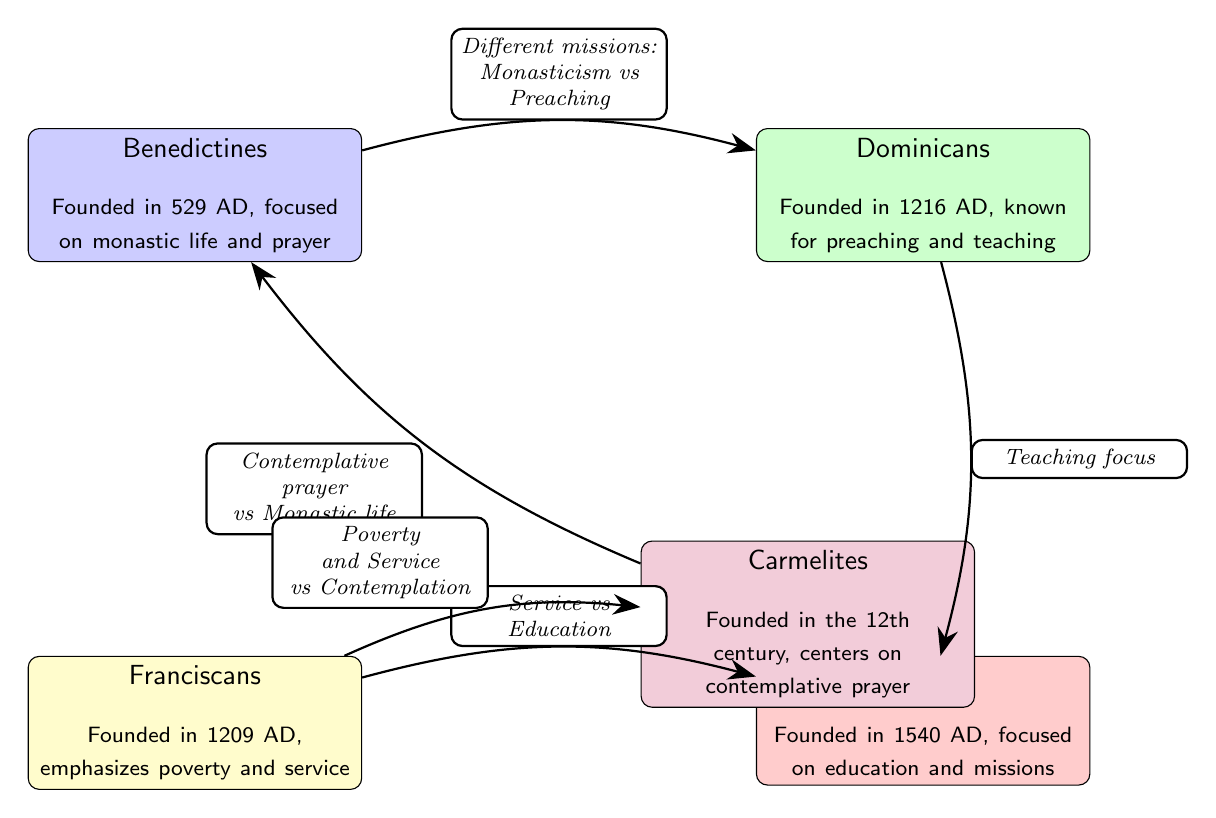What are the names of the religious orders shown in the diagram? The diagram includes five nodes representing different religious orders: Benedictines, Dominicans, Franciscans, Jesuits, and Carmelites.
Answer: Benedictines, Dominicans, Franciscans, Jesuits, Carmelites How many relationships (edges) are between the nodes in the diagram? The diagram displays five edges connecting the nodes. Each edge represents a distinct relationship between two orders.
Answer: 5 Which order emphasizes poverty and service? The Franciscans are specifically noted for their emphasis on poverty and service in the diagram.
Answer: Franciscans What is the main focus of the Dominicans according to the diagram? The Dominicans are recognized for their focus on preaching and teaching, as outlined in the node description.
Answer: Preaching and teaching What are the different missions of the Benedictines compared to the Dominicans? The diagram illustrates that the Benedictines engage in monasticism while the Dominicans pursue preaching, highlighting their different missions.
Answer: Monasticism vs Preaching Which two orders have a relationship centered around contemplative prayer and monastic life? The diagram shows that the Carmelites and Benedictines share a relationship based on contemplative prayer versus monastic life.
Answer: Carmelites and Benedictines What is the role of the Jesuits in the Catholic Church? According to the diagram, the Jesuits have a role focused on education and missions, making them distinct among the listed orders.
Answer: Education and missions How do the Franciscans differ from the Carmelites based on their missions? The Franciscans emphasize service while the Carmelites focus on contemplation, illustrating their differing missions as depicted in the diagram.
Answer: Poverty and Service vs Contemplation What is the foundational year of the Jesuits? The diagram states that the Jesuits were founded in 1540 AD, marking their establishment in Catholic history.
Answer: 1540 AD 